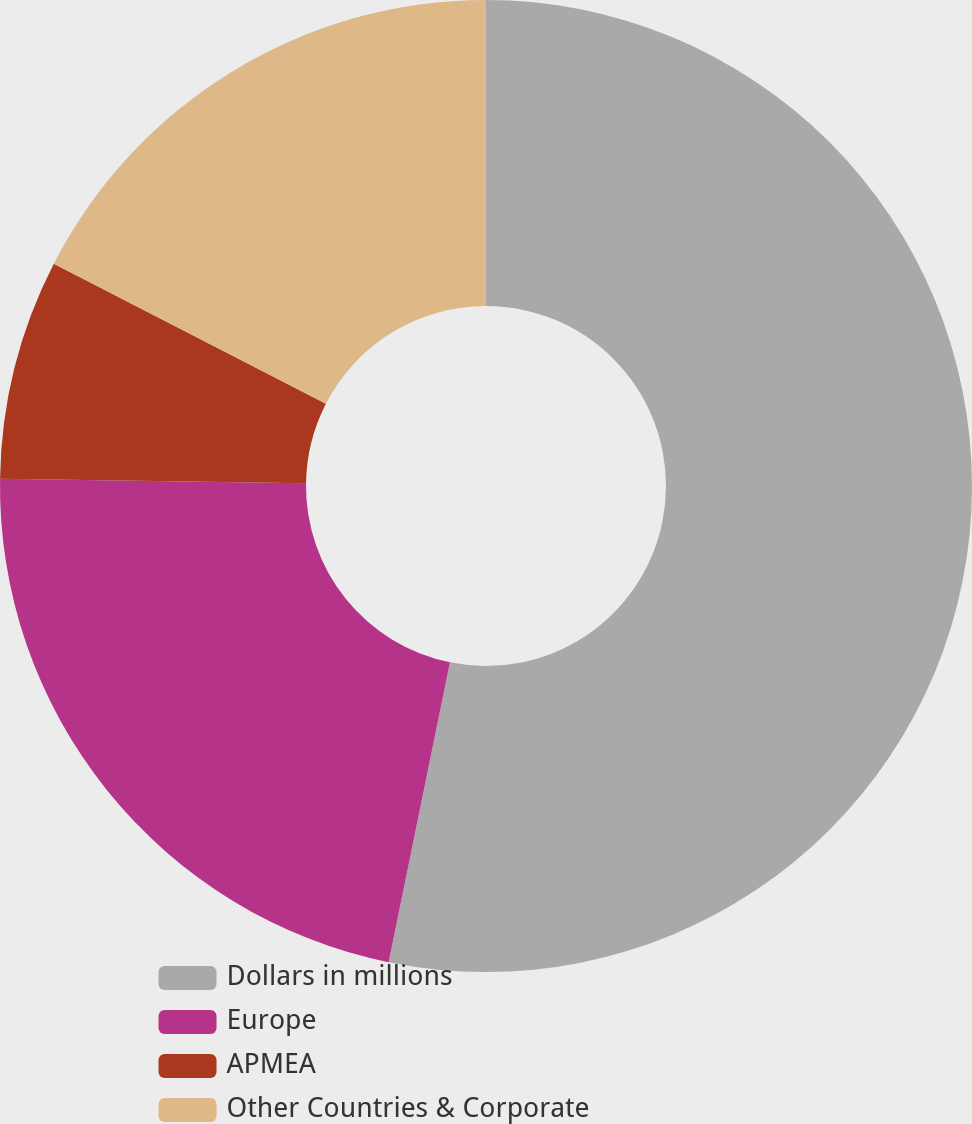<chart> <loc_0><loc_0><loc_500><loc_500><pie_chart><fcel>Dollars in millions<fcel>Europe<fcel>APMEA<fcel>Other Countries & Corporate<nl><fcel>53.21%<fcel>22.03%<fcel>7.32%<fcel>17.44%<nl></chart> 